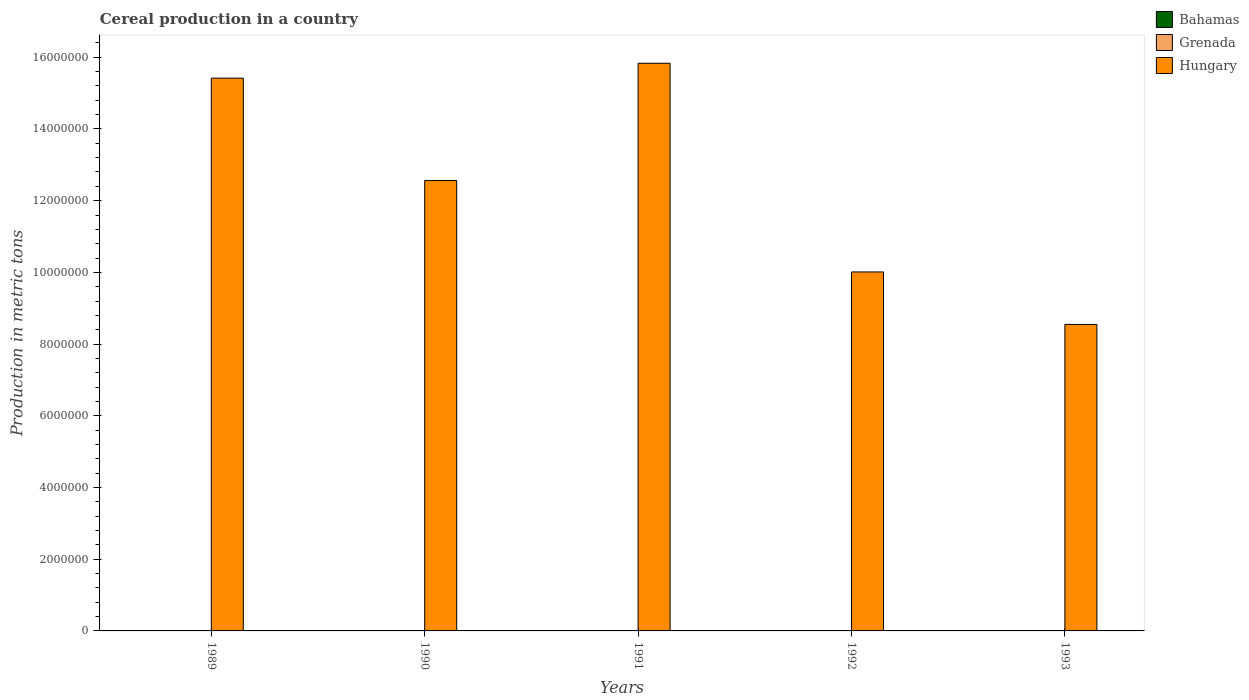Are the number of bars on each tick of the X-axis equal?
Give a very brief answer. Yes. What is the label of the 5th group of bars from the left?
Offer a terse response. 1993. What is the total cereal production in Grenada in 1989?
Your response must be concise. 256. Across all years, what is the maximum total cereal production in Bahamas?
Give a very brief answer. 750. Across all years, what is the minimum total cereal production in Grenada?
Provide a succinct answer. 256. In which year was the total cereal production in Hungary maximum?
Provide a succinct answer. 1991. What is the total total cereal production in Bahamas in the graph?
Your answer should be compact. 3100. What is the difference between the total cereal production in Grenada in 1992 and that in 1993?
Your answer should be compact. -49. What is the difference between the total cereal production in Bahamas in 1993 and the total cereal production in Grenada in 1991?
Provide a short and direct response. 105. What is the average total cereal production in Grenada per year?
Give a very brief answer. 306.4. In the year 1991, what is the difference between the total cereal production in Bahamas and total cereal production in Grenada?
Offer a terse response. 455. Is the total cereal production in Grenada in 1992 less than that in 1993?
Make the answer very short. Yes. Is the difference between the total cereal production in Bahamas in 1989 and 1990 greater than the difference between the total cereal production in Grenada in 1989 and 1990?
Offer a terse response. No. What is the difference between the highest and the second highest total cereal production in Hungary?
Make the answer very short. 4.16e+05. What is the difference between the highest and the lowest total cereal production in Grenada?
Keep it short and to the point. 130. What does the 1st bar from the left in 1992 represents?
Offer a very short reply. Bahamas. What does the 3rd bar from the right in 1990 represents?
Your answer should be compact. Bahamas. How many bars are there?
Your response must be concise. 15. How many years are there in the graph?
Provide a succinct answer. 5. What is the difference between two consecutive major ticks on the Y-axis?
Your response must be concise. 2.00e+06. Are the values on the major ticks of Y-axis written in scientific E-notation?
Give a very brief answer. No. Does the graph contain any zero values?
Offer a terse response. No. Does the graph contain grids?
Give a very brief answer. No. How are the legend labels stacked?
Give a very brief answer. Vertical. What is the title of the graph?
Offer a very short reply. Cereal production in a country. What is the label or title of the X-axis?
Provide a succinct answer. Years. What is the label or title of the Y-axis?
Provide a succinct answer. Production in metric tons. What is the Production in metric tons of Bahamas in 1989?
Your response must be concise. 700. What is the Production in metric tons in Grenada in 1989?
Provide a short and direct response. 256. What is the Production in metric tons of Hungary in 1989?
Provide a short and direct response. 1.54e+07. What is the Production in metric tons of Bahamas in 1990?
Make the answer very short. 750. What is the Production in metric tons in Grenada in 1990?
Keep it short and to the point. 258. What is the Production in metric tons of Hungary in 1990?
Give a very brief answer. 1.26e+07. What is the Production in metric tons of Bahamas in 1991?
Your response must be concise. 750. What is the Production in metric tons of Grenada in 1991?
Provide a succinct answer. 295. What is the Production in metric tons of Hungary in 1991?
Provide a succinct answer. 1.58e+07. What is the Production in metric tons of Grenada in 1992?
Provide a short and direct response. 337. What is the Production in metric tons in Hungary in 1992?
Your answer should be compact. 1.00e+07. What is the Production in metric tons of Grenada in 1993?
Your answer should be very brief. 386. What is the Production in metric tons of Hungary in 1993?
Make the answer very short. 8.55e+06. Across all years, what is the maximum Production in metric tons in Bahamas?
Make the answer very short. 750. Across all years, what is the maximum Production in metric tons of Grenada?
Your answer should be compact. 386. Across all years, what is the maximum Production in metric tons of Hungary?
Your answer should be very brief. 1.58e+07. Across all years, what is the minimum Production in metric tons in Bahamas?
Give a very brief answer. 400. Across all years, what is the minimum Production in metric tons in Grenada?
Ensure brevity in your answer.  256. Across all years, what is the minimum Production in metric tons in Hungary?
Offer a terse response. 8.55e+06. What is the total Production in metric tons in Bahamas in the graph?
Your answer should be very brief. 3100. What is the total Production in metric tons of Grenada in the graph?
Your answer should be very brief. 1532. What is the total Production in metric tons of Hungary in the graph?
Your response must be concise. 6.24e+07. What is the difference between the Production in metric tons of Bahamas in 1989 and that in 1990?
Provide a short and direct response. -50. What is the difference between the Production in metric tons in Grenada in 1989 and that in 1990?
Ensure brevity in your answer.  -2. What is the difference between the Production in metric tons of Hungary in 1989 and that in 1990?
Ensure brevity in your answer.  2.86e+06. What is the difference between the Production in metric tons in Bahamas in 1989 and that in 1991?
Provide a succinct answer. -50. What is the difference between the Production in metric tons in Grenada in 1989 and that in 1991?
Ensure brevity in your answer.  -39. What is the difference between the Production in metric tons in Hungary in 1989 and that in 1991?
Offer a very short reply. -4.16e+05. What is the difference between the Production in metric tons in Grenada in 1989 and that in 1992?
Your answer should be compact. -81. What is the difference between the Production in metric tons of Hungary in 1989 and that in 1992?
Provide a short and direct response. 5.40e+06. What is the difference between the Production in metric tons in Bahamas in 1989 and that in 1993?
Provide a short and direct response. 300. What is the difference between the Production in metric tons in Grenada in 1989 and that in 1993?
Provide a short and direct response. -130. What is the difference between the Production in metric tons of Hungary in 1989 and that in 1993?
Your answer should be very brief. 6.87e+06. What is the difference between the Production in metric tons of Bahamas in 1990 and that in 1991?
Offer a very short reply. 0. What is the difference between the Production in metric tons of Grenada in 1990 and that in 1991?
Your answer should be compact. -37. What is the difference between the Production in metric tons of Hungary in 1990 and that in 1991?
Provide a succinct answer. -3.27e+06. What is the difference between the Production in metric tons of Bahamas in 1990 and that in 1992?
Your answer should be compact. 250. What is the difference between the Production in metric tons of Grenada in 1990 and that in 1992?
Your response must be concise. -79. What is the difference between the Production in metric tons of Hungary in 1990 and that in 1992?
Ensure brevity in your answer.  2.55e+06. What is the difference between the Production in metric tons of Bahamas in 1990 and that in 1993?
Your answer should be compact. 350. What is the difference between the Production in metric tons of Grenada in 1990 and that in 1993?
Make the answer very short. -128. What is the difference between the Production in metric tons in Hungary in 1990 and that in 1993?
Offer a terse response. 4.01e+06. What is the difference between the Production in metric tons in Bahamas in 1991 and that in 1992?
Your response must be concise. 250. What is the difference between the Production in metric tons of Grenada in 1991 and that in 1992?
Offer a very short reply. -42. What is the difference between the Production in metric tons in Hungary in 1991 and that in 1992?
Provide a succinct answer. 5.82e+06. What is the difference between the Production in metric tons of Bahamas in 1991 and that in 1993?
Provide a short and direct response. 350. What is the difference between the Production in metric tons in Grenada in 1991 and that in 1993?
Make the answer very short. -91. What is the difference between the Production in metric tons in Hungary in 1991 and that in 1993?
Your answer should be very brief. 7.28e+06. What is the difference between the Production in metric tons in Bahamas in 1992 and that in 1993?
Offer a very short reply. 100. What is the difference between the Production in metric tons of Grenada in 1992 and that in 1993?
Your answer should be very brief. -49. What is the difference between the Production in metric tons in Hungary in 1992 and that in 1993?
Your answer should be compact. 1.46e+06. What is the difference between the Production in metric tons in Bahamas in 1989 and the Production in metric tons in Grenada in 1990?
Keep it short and to the point. 442. What is the difference between the Production in metric tons in Bahamas in 1989 and the Production in metric tons in Hungary in 1990?
Make the answer very short. -1.26e+07. What is the difference between the Production in metric tons in Grenada in 1989 and the Production in metric tons in Hungary in 1990?
Your answer should be very brief. -1.26e+07. What is the difference between the Production in metric tons of Bahamas in 1989 and the Production in metric tons of Grenada in 1991?
Provide a short and direct response. 405. What is the difference between the Production in metric tons of Bahamas in 1989 and the Production in metric tons of Hungary in 1991?
Your answer should be very brief. -1.58e+07. What is the difference between the Production in metric tons in Grenada in 1989 and the Production in metric tons in Hungary in 1991?
Keep it short and to the point. -1.58e+07. What is the difference between the Production in metric tons of Bahamas in 1989 and the Production in metric tons of Grenada in 1992?
Keep it short and to the point. 363. What is the difference between the Production in metric tons of Bahamas in 1989 and the Production in metric tons of Hungary in 1992?
Your response must be concise. -1.00e+07. What is the difference between the Production in metric tons in Grenada in 1989 and the Production in metric tons in Hungary in 1992?
Make the answer very short. -1.00e+07. What is the difference between the Production in metric tons in Bahamas in 1989 and the Production in metric tons in Grenada in 1993?
Provide a succinct answer. 314. What is the difference between the Production in metric tons in Bahamas in 1989 and the Production in metric tons in Hungary in 1993?
Your response must be concise. -8.55e+06. What is the difference between the Production in metric tons in Grenada in 1989 and the Production in metric tons in Hungary in 1993?
Keep it short and to the point. -8.55e+06. What is the difference between the Production in metric tons of Bahamas in 1990 and the Production in metric tons of Grenada in 1991?
Your response must be concise. 455. What is the difference between the Production in metric tons in Bahamas in 1990 and the Production in metric tons in Hungary in 1991?
Keep it short and to the point. -1.58e+07. What is the difference between the Production in metric tons of Grenada in 1990 and the Production in metric tons of Hungary in 1991?
Offer a terse response. -1.58e+07. What is the difference between the Production in metric tons of Bahamas in 1990 and the Production in metric tons of Grenada in 1992?
Offer a terse response. 413. What is the difference between the Production in metric tons in Bahamas in 1990 and the Production in metric tons in Hungary in 1992?
Give a very brief answer. -1.00e+07. What is the difference between the Production in metric tons in Grenada in 1990 and the Production in metric tons in Hungary in 1992?
Your response must be concise. -1.00e+07. What is the difference between the Production in metric tons of Bahamas in 1990 and the Production in metric tons of Grenada in 1993?
Offer a very short reply. 364. What is the difference between the Production in metric tons of Bahamas in 1990 and the Production in metric tons of Hungary in 1993?
Ensure brevity in your answer.  -8.55e+06. What is the difference between the Production in metric tons in Grenada in 1990 and the Production in metric tons in Hungary in 1993?
Your answer should be very brief. -8.55e+06. What is the difference between the Production in metric tons of Bahamas in 1991 and the Production in metric tons of Grenada in 1992?
Make the answer very short. 413. What is the difference between the Production in metric tons of Bahamas in 1991 and the Production in metric tons of Hungary in 1992?
Offer a very short reply. -1.00e+07. What is the difference between the Production in metric tons in Grenada in 1991 and the Production in metric tons in Hungary in 1992?
Your response must be concise. -1.00e+07. What is the difference between the Production in metric tons in Bahamas in 1991 and the Production in metric tons in Grenada in 1993?
Make the answer very short. 364. What is the difference between the Production in metric tons of Bahamas in 1991 and the Production in metric tons of Hungary in 1993?
Your response must be concise. -8.55e+06. What is the difference between the Production in metric tons of Grenada in 1991 and the Production in metric tons of Hungary in 1993?
Offer a very short reply. -8.55e+06. What is the difference between the Production in metric tons of Bahamas in 1992 and the Production in metric tons of Grenada in 1993?
Your response must be concise. 114. What is the difference between the Production in metric tons in Bahamas in 1992 and the Production in metric tons in Hungary in 1993?
Your answer should be compact. -8.55e+06. What is the difference between the Production in metric tons of Grenada in 1992 and the Production in metric tons of Hungary in 1993?
Keep it short and to the point. -8.55e+06. What is the average Production in metric tons of Bahamas per year?
Keep it short and to the point. 620. What is the average Production in metric tons of Grenada per year?
Provide a succinct answer. 306.4. What is the average Production in metric tons of Hungary per year?
Provide a succinct answer. 1.25e+07. In the year 1989, what is the difference between the Production in metric tons in Bahamas and Production in metric tons in Grenada?
Offer a terse response. 444. In the year 1989, what is the difference between the Production in metric tons of Bahamas and Production in metric tons of Hungary?
Offer a very short reply. -1.54e+07. In the year 1989, what is the difference between the Production in metric tons of Grenada and Production in metric tons of Hungary?
Your answer should be compact. -1.54e+07. In the year 1990, what is the difference between the Production in metric tons of Bahamas and Production in metric tons of Grenada?
Offer a terse response. 492. In the year 1990, what is the difference between the Production in metric tons in Bahamas and Production in metric tons in Hungary?
Offer a terse response. -1.26e+07. In the year 1990, what is the difference between the Production in metric tons in Grenada and Production in metric tons in Hungary?
Your answer should be very brief. -1.26e+07. In the year 1991, what is the difference between the Production in metric tons in Bahamas and Production in metric tons in Grenada?
Your answer should be compact. 455. In the year 1991, what is the difference between the Production in metric tons of Bahamas and Production in metric tons of Hungary?
Your answer should be compact. -1.58e+07. In the year 1991, what is the difference between the Production in metric tons in Grenada and Production in metric tons in Hungary?
Give a very brief answer. -1.58e+07. In the year 1992, what is the difference between the Production in metric tons of Bahamas and Production in metric tons of Grenada?
Offer a very short reply. 163. In the year 1992, what is the difference between the Production in metric tons in Bahamas and Production in metric tons in Hungary?
Provide a succinct answer. -1.00e+07. In the year 1992, what is the difference between the Production in metric tons of Grenada and Production in metric tons of Hungary?
Offer a terse response. -1.00e+07. In the year 1993, what is the difference between the Production in metric tons of Bahamas and Production in metric tons of Hungary?
Give a very brief answer. -8.55e+06. In the year 1993, what is the difference between the Production in metric tons in Grenada and Production in metric tons in Hungary?
Offer a terse response. -8.55e+06. What is the ratio of the Production in metric tons in Hungary in 1989 to that in 1990?
Give a very brief answer. 1.23. What is the ratio of the Production in metric tons in Grenada in 1989 to that in 1991?
Provide a short and direct response. 0.87. What is the ratio of the Production in metric tons of Hungary in 1989 to that in 1991?
Give a very brief answer. 0.97. What is the ratio of the Production in metric tons of Bahamas in 1989 to that in 1992?
Keep it short and to the point. 1.4. What is the ratio of the Production in metric tons in Grenada in 1989 to that in 1992?
Provide a succinct answer. 0.76. What is the ratio of the Production in metric tons in Hungary in 1989 to that in 1992?
Give a very brief answer. 1.54. What is the ratio of the Production in metric tons in Grenada in 1989 to that in 1993?
Provide a succinct answer. 0.66. What is the ratio of the Production in metric tons in Hungary in 1989 to that in 1993?
Offer a terse response. 1.8. What is the ratio of the Production in metric tons in Grenada in 1990 to that in 1991?
Make the answer very short. 0.87. What is the ratio of the Production in metric tons in Hungary in 1990 to that in 1991?
Provide a short and direct response. 0.79. What is the ratio of the Production in metric tons of Bahamas in 1990 to that in 1992?
Keep it short and to the point. 1.5. What is the ratio of the Production in metric tons in Grenada in 1990 to that in 1992?
Your answer should be very brief. 0.77. What is the ratio of the Production in metric tons of Hungary in 1990 to that in 1992?
Offer a very short reply. 1.25. What is the ratio of the Production in metric tons in Bahamas in 1990 to that in 1993?
Keep it short and to the point. 1.88. What is the ratio of the Production in metric tons in Grenada in 1990 to that in 1993?
Provide a succinct answer. 0.67. What is the ratio of the Production in metric tons of Hungary in 1990 to that in 1993?
Provide a succinct answer. 1.47. What is the ratio of the Production in metric tons in Bahamas in 1991 to that in 1992?
Keep it short and to the point. 1.5. What is the ratio of the Production in metric tons in Grenada in 1991 to that in 1992?
Your response must be concise. 0.88. What is the ratio of the Production in metric tons of Hungary in 1991 to that in 1992?
Make the answer very short. 1.58. What is the ratio of the Production in metric tons of Bahamas in 1991 to that in 1993?
Provide a short and direct response. 1.88. What is the ratio of the Production in metric tons of Grenada in 1991 to that in 1993?
Offer a terse response. 0.76. What is the ratio of the Production in metric tons in Hungary in 1991 to that in 1993?
Your response must be concise. 1.85. What is the ratio of the Production in metric tons of Grenada in 1992 to that in 1993?
Your answer should be very brief. 0.87. What is the ratio of the Production in metric tons of Hungary in 1992 to that in 1993?
Offer a very short reply. 1.17. What is the difference between the highest and the second highest Production in metric tons in Bahamas?
Your answer should be very brief. 0. What is the difference between the highest and the second highest Production in metric tons of Hungary?
Provide a short and direct response. 4.16e+05. What is the difference between the highest and the lowest Production in metric tons in Bahamas?
Provide a short and direct response. 350. What is the difference between the highest and the lowest Production in metric tons of Grenada?
Provide a short and direct response. 130. What is the difference between the highest and the lowest Production in metric tons of Hungary?
Provide a short and direct response. 7.28e+06. 